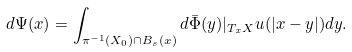<formula> <loc_0><loc_0><loc_500><loc_500>d \Psi ( x ) = \int _ { \pi ^ { - 1 } ( X _ { 0 } ) \cap B _ { s } ( x ) } d \bar { \Phi } ( y ) | _ { T _ { x } X } u ( | x - y | ) d y .</formula> 